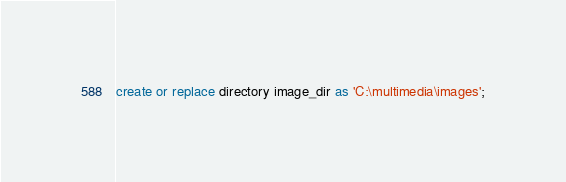Convert code to text. <code><loc_0><loc_0><loc_500><loc_500><_SQL_>create or replace directory image_dir as 'C:\multimedia\images';</code> 